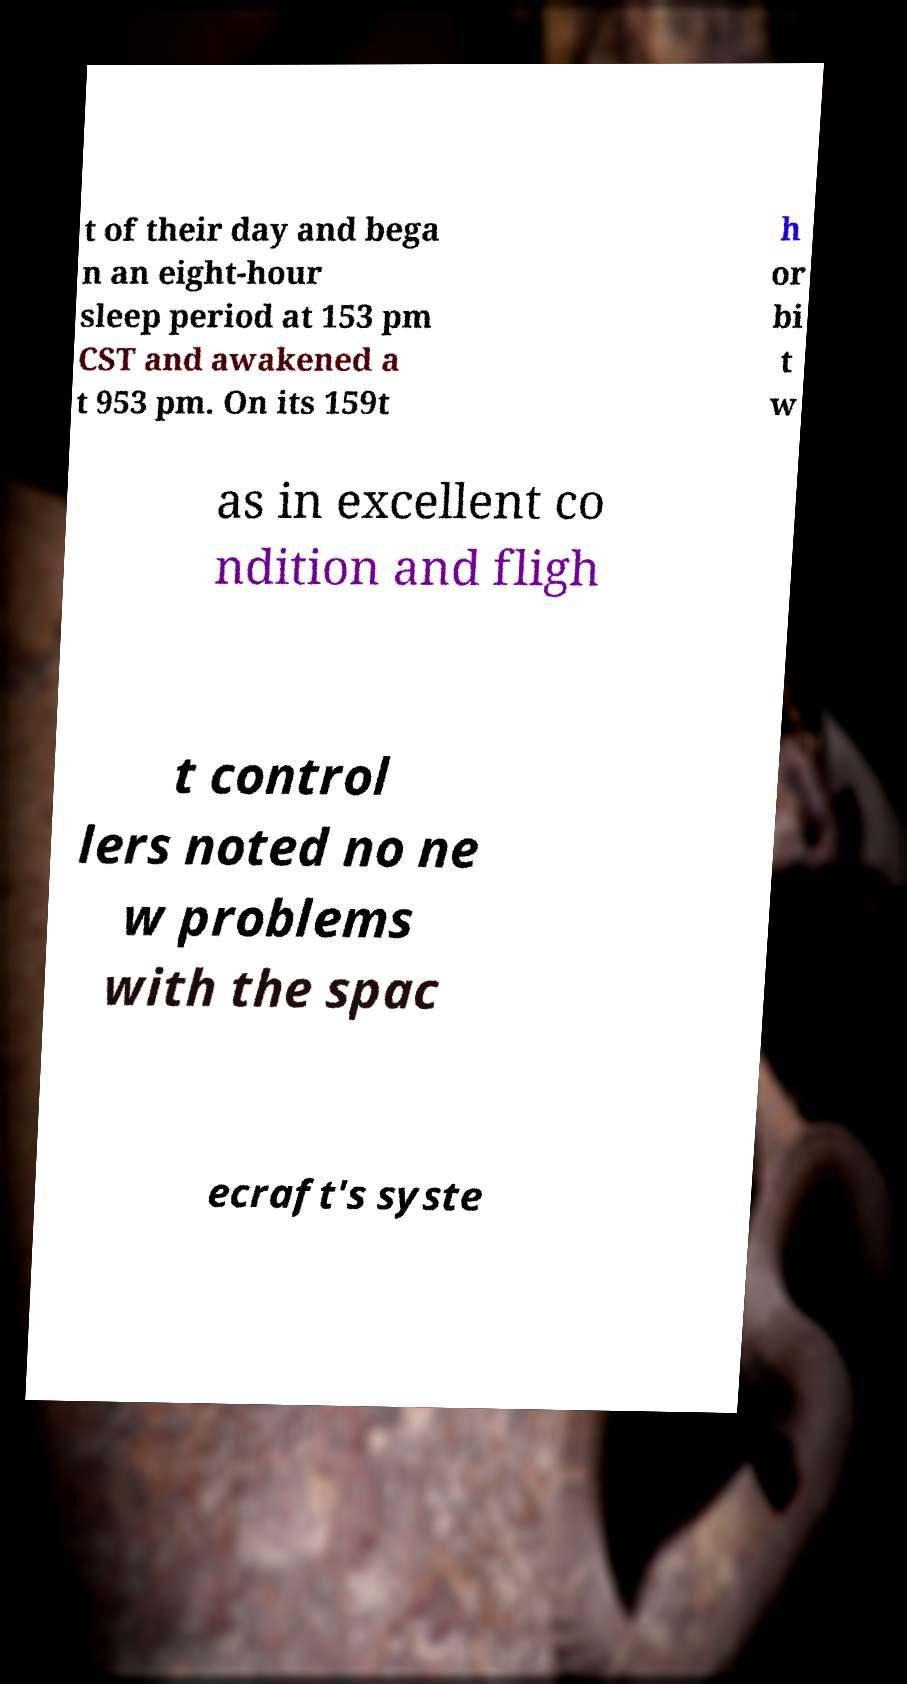For documentation purposes, I need the text within this image transcribed. Could you provide that? t of their day and bega n an eight-hour sleep period at 153 pm CST and awakened a t 953 pm. On its 159t h or bi t w as in excellent co ndition and fligh t control lers noted no ne w problems with the spac ecraft's syste 